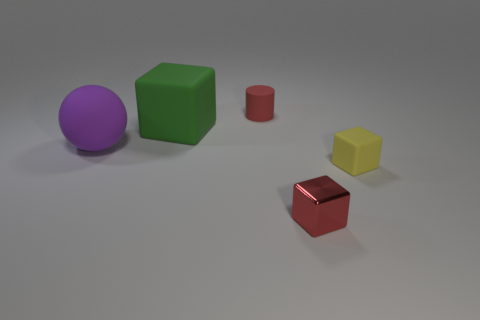Subtract all tiny metallic blocks. How many blocks are left? 2 Add 4 small blue cylinders. How many objects exist? 9 Subtract all spheres. How many objects are left? 4 Subtract all green cubes. How many cubes are left? 2 Subtract 0 blue blocks. How many objects are left? 5 Subtract all purple blocks. Subtract all red balls. How many blocks are left? 3 Subtract all small red cylinders. Subtract all big green things. How many objects are left? 3 Add 1 big purple matte balls. How many big purple matte balls are left? 2 Add 2 cyan metallic objects. How many cyan metallic objects exist? 2 